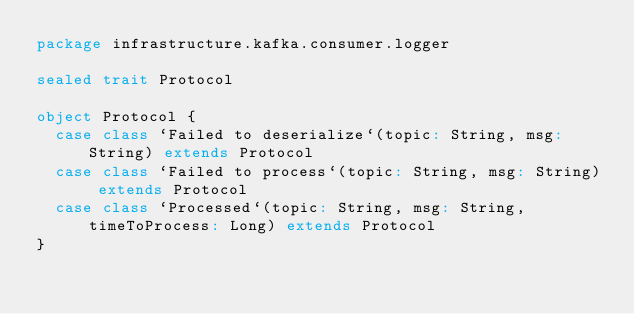<code> <loc_0><loc_0><loc_500><loc_500><_Scala_>package infrastructure.kafka.consumer.logger

sealed trait Protocol

object Protocol {
  case class `Failed to deserialize`(topic: String, msg: String) extends Protocol
  case class `Failed to process`(topic: String, msg: String) extends Protocol
  case class `Processed`(topic: String, msg: String, timeToProcess: Long) extends Protocol
}
</code> 